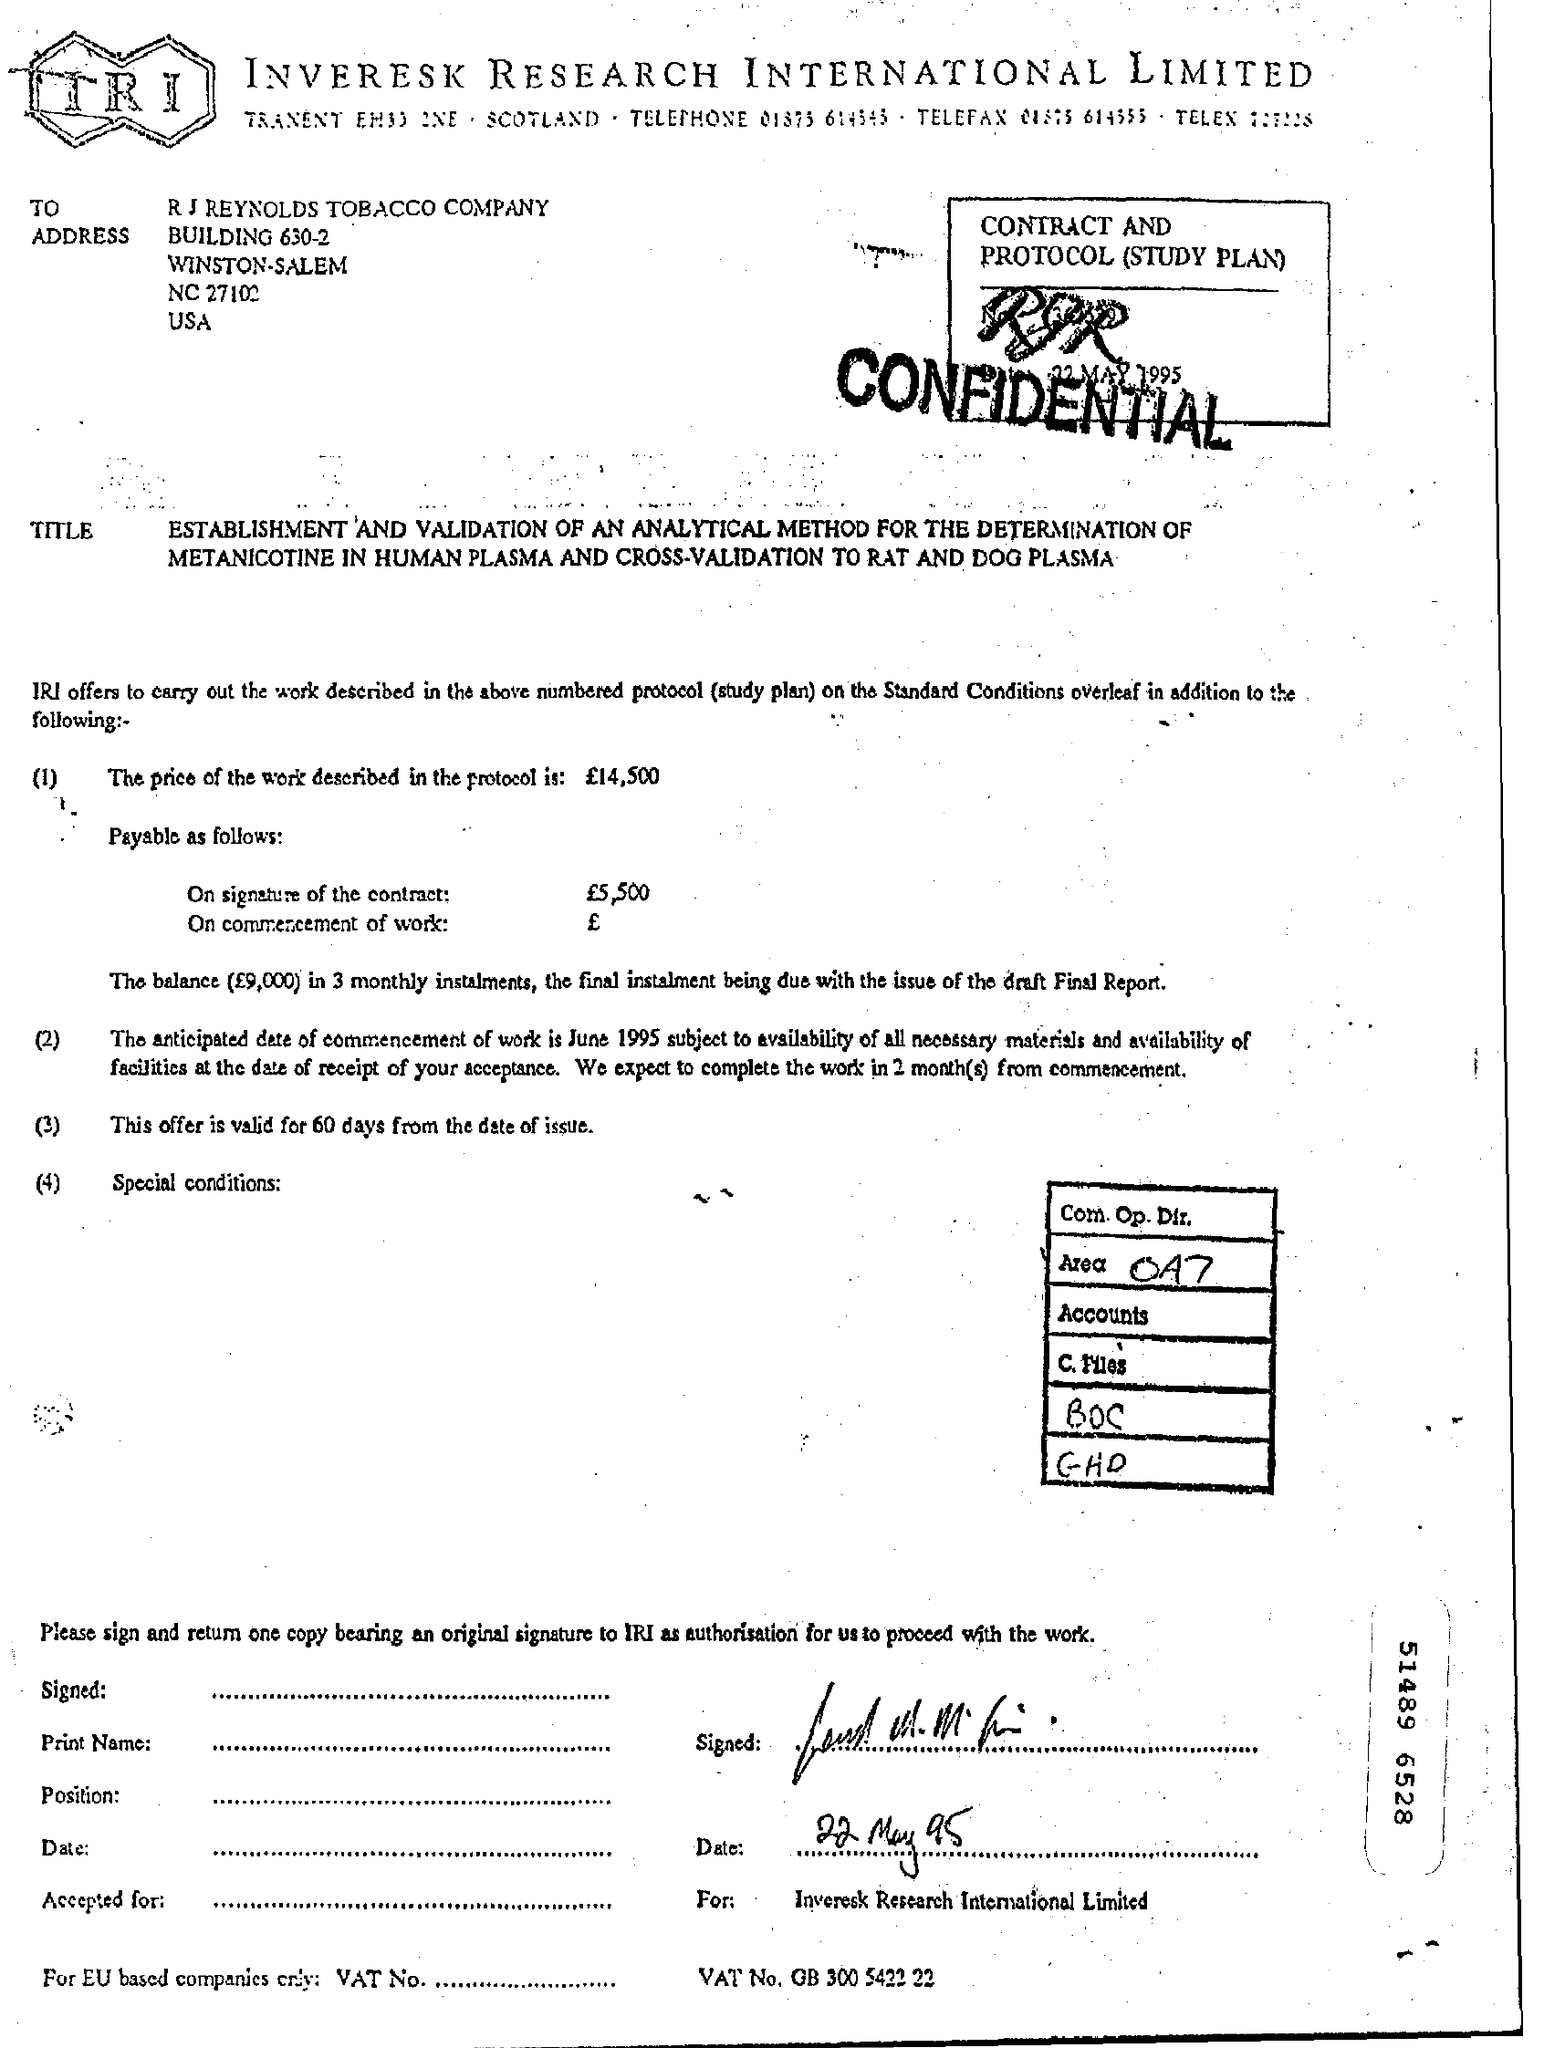To Whom is this Fax addressed to?
Offer a terse response. R J Reynolds Tobacco Company. How long is the offer valid for?
Your answer should be very brief. 60 days from the date of issue. 